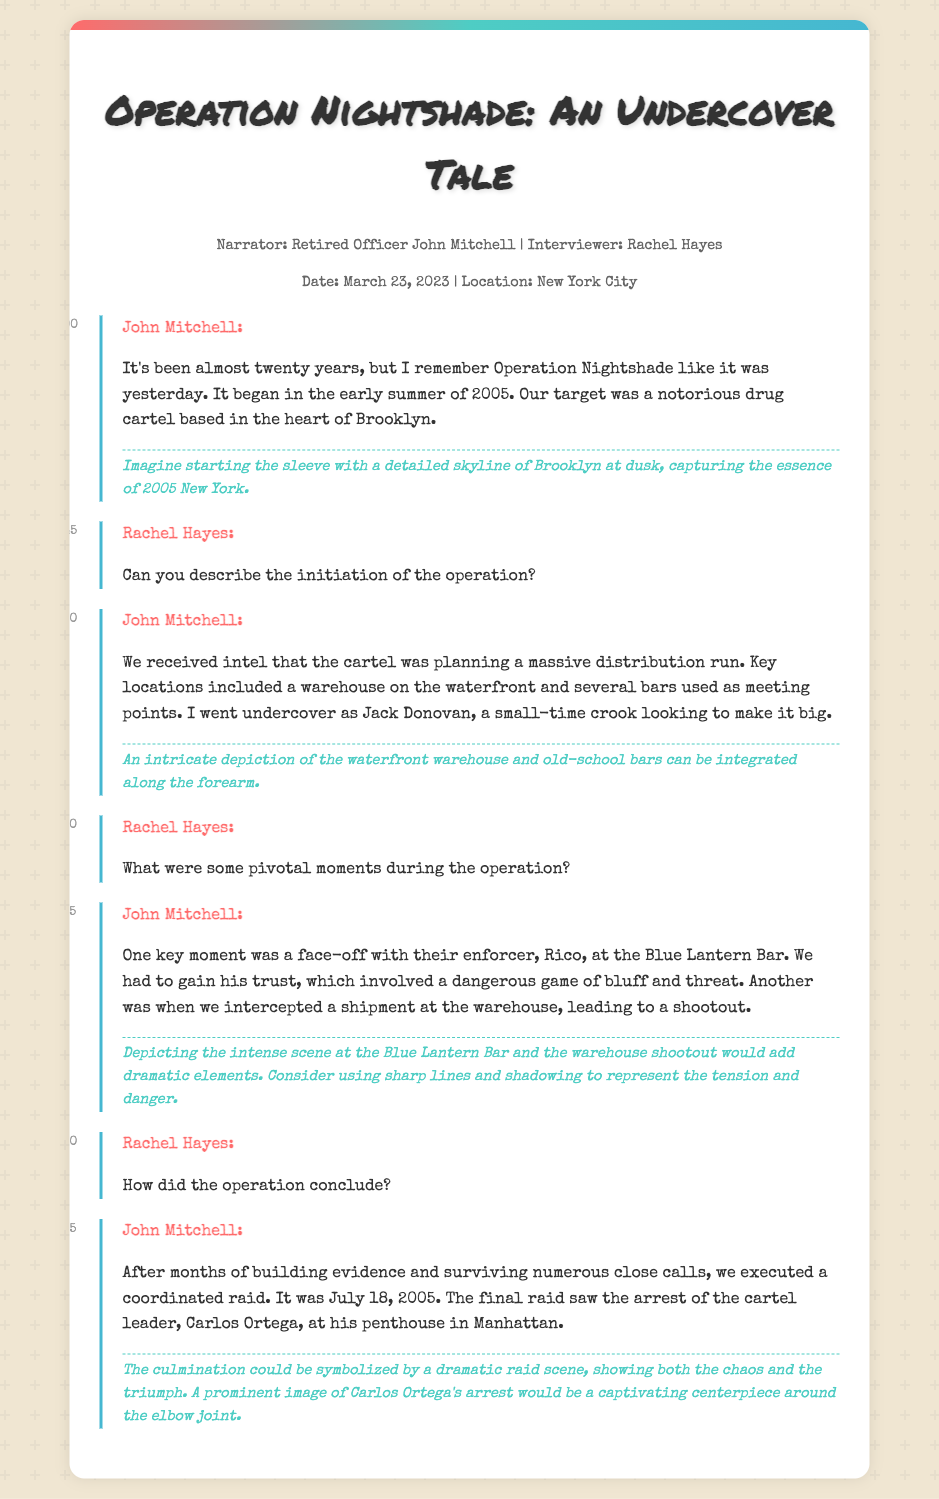What is the title of the operation? The title of the operation is stated in the header of the document.
Answer: Operation Nightshade Who is the narrator of the transcript? The narrator is introduced at the beginning of the document.
Answer: Retired Officer John Mitchell What date did the operation commence? The year of commencement is mentioned in the dialogue by the narrator.
Answer: 2005 What location was targeted for the operation? The specific location is detailed in the first dialogue of the narrator.
Answer: Brooklyn How did Officer Mitchell go undercover? This detail is provided when he describes his undercover persona.
Answer: Jack Donovan What was a pivotal moment during the operation? The narrator describes significant events and identifies one key moment in the operation.
Answer: Face-off with Rico at the Blue Lantern Bar When did the operation conclude? The conclusion date is provided by Officer Mitchell in the transcript.
Answer: July 18, 2005 What was the outcome of the final raid? The outcome is discussed in the dialogue regarding the conclusion of the operation.
Answer: Arrest of Carlos Ortega What artistic interpretation is suggested for the warehouse scene? The document includes artistic notes related to different parts of the operation.
Answer: Dramatic elements with sharp lines and shadowing 